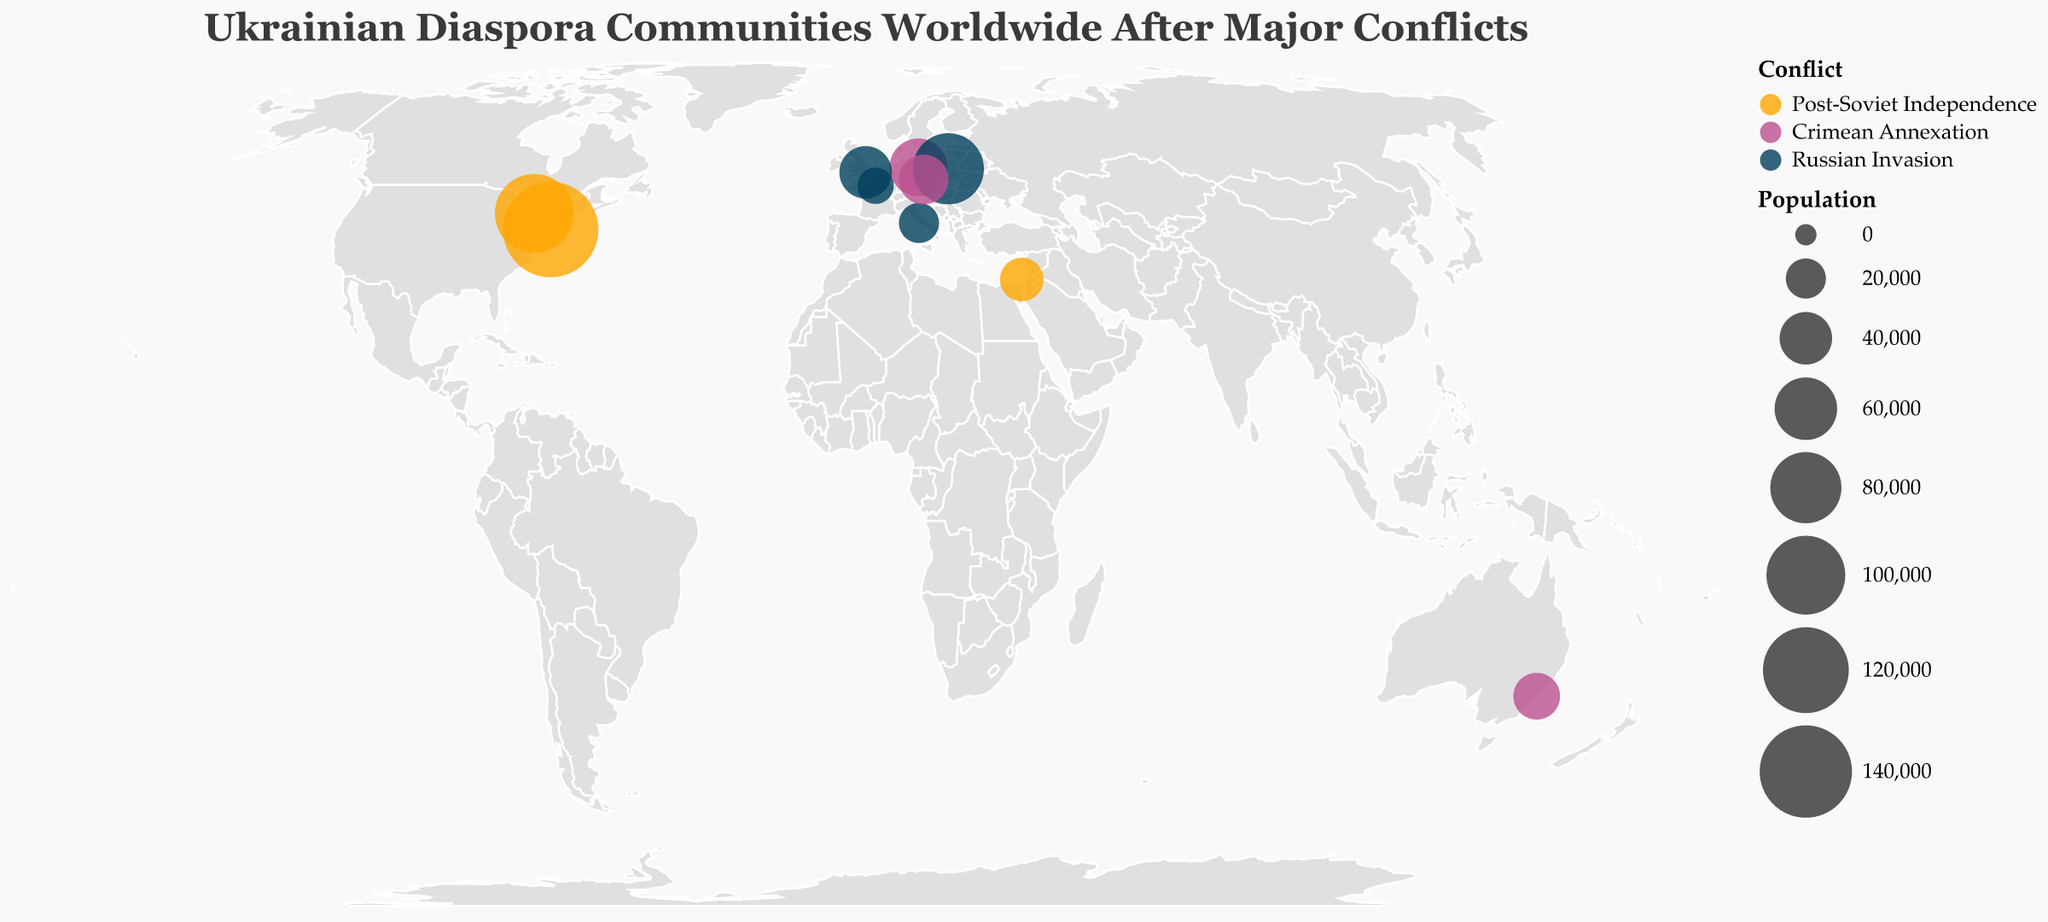Where is the largest Ukrainian diaspora community located following major conflicts? According to the plot, the largest Ukrainian diaspora community is represented by the largest circle. The largest circle is located in New York, United States, with a population of 150000.
Answer: New York, United States Which conflicts saw the highest number of Ukrainian diaspora communities forming? By examining the colors and number of data points for each conflict, one can see that the "Russian Invasion" is represented by multiple large circles, indicating higher numbers of Ukrainian diaspora communities formed.
Answer: Russian Invasion Compare the populations of Ukrainian diaspora communities in Toronto and Sydney. Which one is larger and by how much? Toronto has a population of 100000, while Sydney has a population of 30000. The difference between them is 100000 - 30000, which is 70000.
Answer: Toronto by 70000 In which year did the most diverse distribution of Ukrainian diaspora communities occur? By looking at the population data and the years, 2022 has the most diverse distribution with communities in Warsaw, London, Rome, and Paris.
Answer: 2022 Which city has the smallest Ukrainian diaspora community and from which conflict did it emerge? The smallest circle represents the smallest community. Paris has the smallest community with a population of 15000, emerging from the Russian Invasion conflict.
Answer: Paris, Russian Invasion Calculate the average population size of Ukrainian diaspora communities formed during the Crimean Annexation. The Crimean Annexation communities are Berlin (50000), Sydney (30000), and Prague (35000). The average is (50000 + 30000 + 35000) / 3, which equals 38333.33.
Answer: 38333.33 What is the total population of Ukrainian diaspora communities formed in the European countries after the Russian Invasion? The European countries involved are Poland (80000), United Kingdom (40000), Italy (20000), and France (15000). The total population is 80000 + 40000 + 20000 + 15000 = 155000.
Answer: 155000 Which conflict led to the formation of the diaspora community in Tel Aviv, and what is its population size? According to the tooltip and colored circles, Tel Aviv emerged after the Post-Soviet Independence conflict with a population of 25000.
Answer: Post-Soviet Independence, 25000 How many cities contain Ukrainian diaspora communities that were formed as a result of the Post-Soviet Independence conflict? The figure shows cities associated with different conflicts using unique colors. Three cities—New York, Toronto, and Tel Aviv—are associated with the Post-Soviet Independence conflict.
Answer: 3 Between Berlin and Prague, which city's Ukrainian diaspora community is larger and from which conflict do they originate? Berlin has a population of 50000 from the Crimean Annexation conflict, while Prague has a population of 35000 from the same conflict. Therefore, Berlin’s community is larger.
Answer: Berlin, Crimean Annexation 